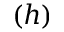Convert formula to latex. <formula><loc_0><loc_0><loc_500><loc_500>( h )</formula> 